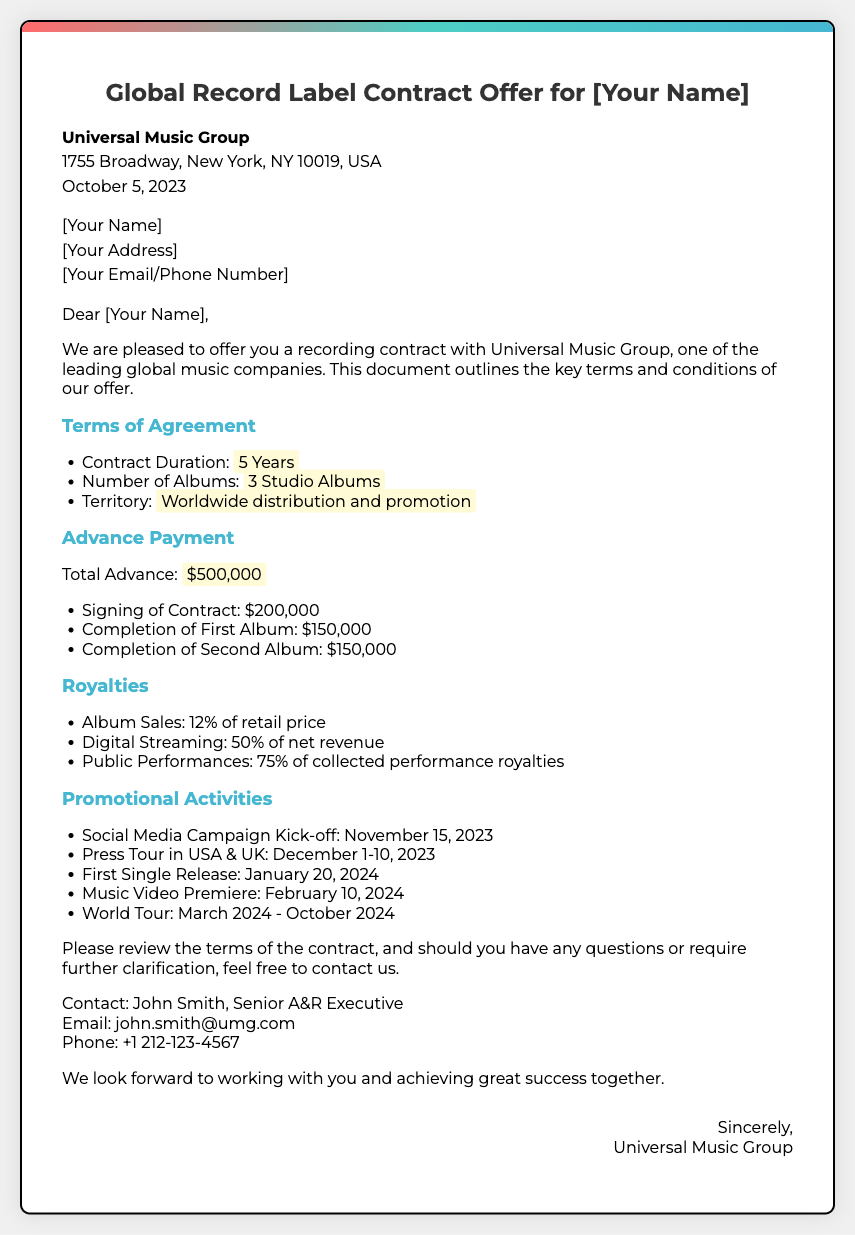What is the total advance payment? The total advance payment is explicitly stated in the document.
Answer: $500,000 What is the contract duration? The document specifies the length of the contract clearly.
Answer: 5 Years How many studio albums are required? The number of albums is directly mentioned in the terms of the agreement.
Answer: 3 Studio Albums What percentage of retail price is paid for album sales royalties? The document provides the percentage for album sales royalties.
Answer: 12% When does the social media campaign kick-off? The timeline for promotional activities states the date for the social media campaign.
Answer: November 15, 2023 Who is the contact person for further questions? The document lists the contact person for any inquiries.
Answer: John Smith What is the first single release date? The specific date for the first single release is mentioned in the promotional activities section.
Answer: January 20, 2024 What percentage of net revenue is provided for digital streaming royalties? The document outlines the revenue percentage specifically for digital streaming.
Answer: 50% What is the location of Universal Music Group's headquarters? The address is included in the header of the document.
Answer: 1755 Broadway, New York, NY 10019, USA 